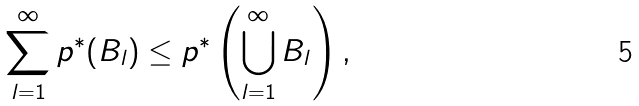Convert formula to latex. <formula><loc_0><loc_0><loc_500><loc_500>\sum _ { l = 1 } ^ { \infty } p ^ { * } ( B _ { l } ) \leq p ^ { * } \left ( \bigcup _ { l = 1 } ^ { \infty } B _ { l } \right ) ,</formula> 